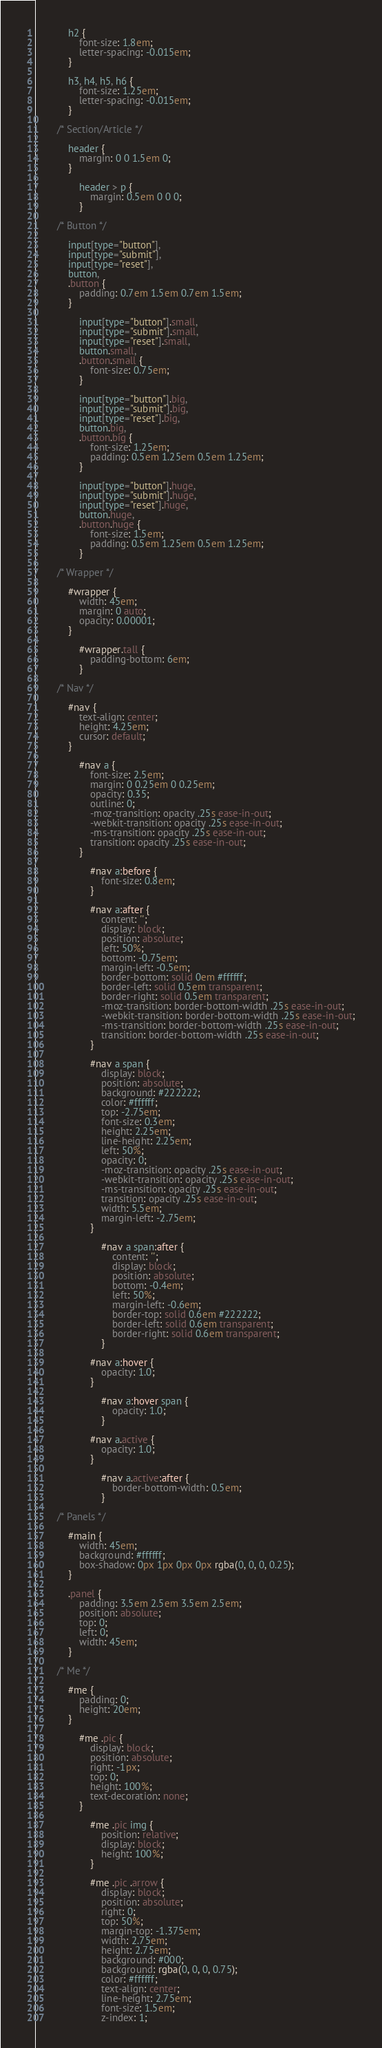<code> <loc_0><loc_0><loc_500><loc_500><_CSS_>
			h2 {
				font-size: 1.8em;
				letter-spacing: -0.015em;
			}

			h3, h4, h5, h6 {
				font-size: 1.25em;
				letter-spacing: -0.015em;
			}

		/* Section/Article */

			header {
				margin: 0 0 1.5em 0;
			}

				header > p {
					margin: 0.5em 0 0 0;
				}

		/* Button */

			input[type="button"],
			input[type="submit"],
			input[type="reset"],
			button,
			.button {
				padding: 0.7em 1.5em 0.7em 1.5em;
			}

				input[type="button"].small,
				input[type="submit"].small,
				input[type="reset"].small,
				button.small,
				.button.small {
					font-size: 0.75em;
				}

				input[type="button"].big,
				input[type="submit"].big,
				input[type="reset"].big,
				button.big,
				.button.big {
					font-size: 1.25em;
					padding: 0.5em 1.25em 0.5em 1.25em;
				}

				input[type="button"].huge,
				input[type="submit"].huge,
				input[type="reset"].huge,
				button.huge,
				.button.huge {
					font-size: 1.5em;
					padding: 0.5em 1.25em 0.5em 1.25em;
				}

		/* Wrapper */

			#wrapper {
				width: 45em;
				margin: 0 auto;
				opacity: 0.00001;
			}

				#wrapper.tall {
					padding-bottom: 6em;
				}

		/* Nav */

			#nav {
				text-align: center;
				height: 4.25em;
				cursor: default;
			}

				#nav a {
					font-size: 2.5em;
					margin: 0 0.25em 0 0.25em;
					opacity: 0.35;
					outline: 0;
					-moz-transition: opacity .25s ease-in-out;
					-webkit-transition: opacity .25s ease-in-out;
					-ms-transition: opacity .25s ease-in-out;
					transition: opacity .25s ease-in-out;
				}

					#nav a:before {
						font-size: 0.8em;
					}

					#nav a:after {
						content: '';
						display: block;
						position: absolute;
						left: 50%;
						bottom: -0.75em;
						margin-left: -0.5em;
						border-bottom: solid 0em #ffffff;
						border-left: solid 0.5em transparent;
						border-right: solid 0.5em transparent;
						-moz-transition: border-bottom-width .25s ease-in-out;
						-webkit-transition: border-bottom-width .25s ease-in-out;
						-ms-transition: border-bottom-width .25s ease-in-out;
						transition: border-bottom-width .25s ease-in-out;
					}

					#nav a span {
						display: block;
						position: absolute;
						background: #222222;
						color: #ffffff;
						top: -2.75em;
						font-size: 0.3em;
						height: 2.25em;
						line-height: 2.25em;
						left: 50%;
						opacity: 0;
						-moz-transition: opacity .25s ease-in-out;
						-webkit-transition: opacity .25s ease-in-out;
						-ms-transition: opacity .25s ease-in-out;
						transition: opacity .25s ease-in-out;
						width: 5.5em;
						margin-left: -2.75em;
					}

						#nav a span:after {
							content: '';
							display: block;
							position: absolute;
							bottom: -0.4em;
							left: 50%;
							margin-left: -0.6em;
							border-top: solid 0.6em #222222;
							border-left: solid 0.6em transparent;
							border-right: solid 0.6em transparent;
						}

					#nav a:hover {
						opacity: 1.0;
					}

						#nav a:hover span {
							opacity: 1.0;
						}

					#nav a.active {
						opacity: 1.0;
					}

						#nav a.active:after {
							border-bottom-width: 0.5em;
						}

		/* Panels */

			#main {
				width: 45em;
				background: #ffffff;
				box-shadow: 0px 1px 0px 0px rgba(0, 0, 0, 0.25);
			}

			.panel {
				padding: 3.5em 2.5em 3.5em 2.5em;
				position: absolute;
				top: 0;
				left: 0;
				width: 45em;
			}

		/* Me */

			#me {
				padding: 0;
				height: 20em;
			}

				#me .pic {
					display: block;
					position: absolute;
					right: -1px;
					top: 0;
					height: 100%;
					text-decoration: none;
				}

					#me .pic img {
						position: relative;
						display: block;
						height: 100%;
					}

					#me .pic .arrow {
						display: block;
						position: absolute;
						right: 0;
						top: 50%;
						margin-top: -1.375em;
						width: 2.75em;
						height: 2.75em;
						background: #000;
						background: rgba(0, 0, 0, 0.75);
						color: #ffffff;
						text-align: center;
						line-height: 2.75em;
						font-size: 1.5em;
						z-index: 1;</code> 